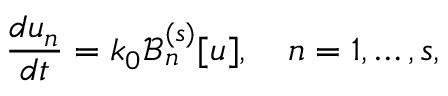<formula> <loc_0><loc_0><loc_500><loc_500>\frac { d u _ { n } } { d t } = k _ { 0 } \mathcal { B } _ { n } ^ { ( s ) } [ u ] , \quad n = 1 , \dots , s ,</formula> 